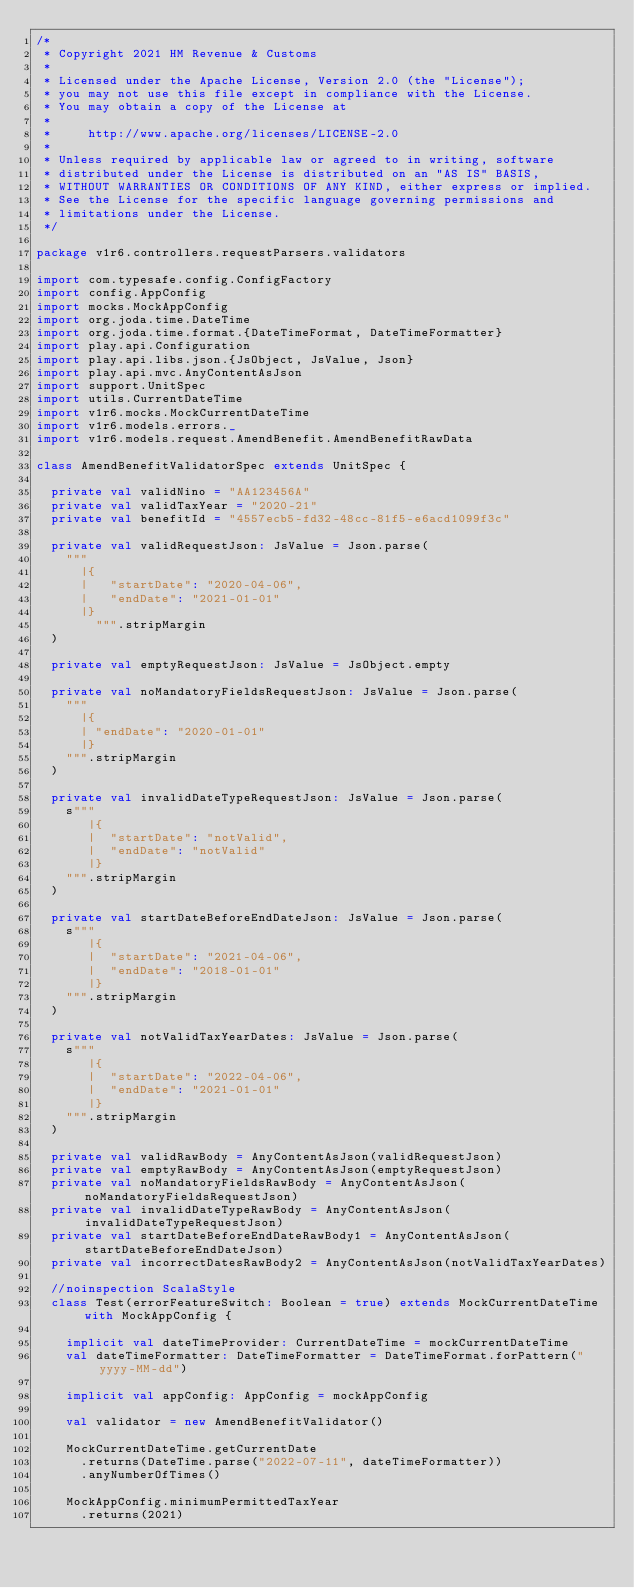Convert code to text. <code><loc_0><loc_0><loc_500><loc_500><_Scala_>/*
 * Copyright 2021 HM Revenue & Customs
 *
 * Licensed under the Apache License, Version 2.0 (the "License");
 * you may not use this file except in compliance with the License.
 * You may obtain a copy of the License at
 *
 *     http://www.apache.org/licenses/LICENSE-2.0
 *
 * Unless required by applicable law or agreed to in writing, software
 * distributed under the License is distributed on an "AS IS" BASIS,
 * WITHOUT WARRANTIES OR CONDITIONS OF ANY KIND, either express or implied.
 * See the License for the specific language governing permissions and
 * limitations under the License.
 */

package v1r6.controllers.requestParsers.validators

import com.typesafe.config.ConfigFactory
import config.AppConfig
import mocks.MockAppConfig
import org.joda.time.DateTime
import org.joda.time.format.{DateTimeFormat, DateTimeFormatter}
import play.api.Configuration
import play.api.libs.json.{JsObject, JsValue, Json}
import play.api.mvc.AnyContentAsJson
import support.UnitSpec
import utils.CurrentDateTime
import v1r6.mocks.MockCurrentDateTime
import v1r6.models.errors._
import v1r6.models.request.AmendBenefit.AmendBenefitRawData

class AmendBenefitValidatorSpec extends UnitSpec {

  private val validNino = "AA123456A"
  private val validTaxYear = "2020-21"
  private val benefitId = "4557ecb5-fd32-48cc-81f5-e6acd1099f3c"

  private val validRequestJson: JsValue = Json.parse(
    """
      |{
      |   "startDate": "2020-04-06",
      |   "endDate": "2021-01-01"
      |}
        """.stripMargin
  )

  private val emptyRequestJson: JsValue = JsObject.empty

  private val noMandatoryFieldsRequestJson: JsValue = Json.parse(
    """
      |{
      | "endDate": "2020-01-01"
      |}
    """.stripMargin
  )

  private val invalidDateTypeRequestJson: JsValue = Json.parse(
    s"""
       |{
       |  "startDate": "notValid",
       |  "endDate": "notValid"
       |}
    """.stripMargin
  )

  private val startDateBeforeEndDateJson: JsValue = Json.parse(
    s"""
       |{
       |  "startDate": "2021-04-06",
       |  "endDate": "2018-01-01"
       |}
    """.stripMargin
  )

  private val notValidTaxYearDates: JsValue = Json.parse(
    s"""
       |{
       |  "startDate": "2022-04-06",
       |  "endDate": "2021-01-01"
       |}
    """.stripMargin
  )

  private val validRawBody = AnyContentAsJson(validRequestJson)
  private val emptyRawBody = AnyContentAsJson(emptyRequestJson)
  private val noMandatoryFieldsRawBody = AnyContentAsJson(noMandatoryFieldsRequestJson)
  private val invalidDateTypeRawBody = AnyContentAsJson(invalidDateTypeRequestJson)
  private val startDateBeforeEndDateRawBody1 = AnyContentAsJson(startDateBeforeEndDateJson)
  private val incorrectDatesRawBody2 = AnyContentAsJson(notValidTaxYearDates)

  //noinspection ScalaStyle
  class Test(errorFeatureSwitch: Boolean = true) extends MockCurrentDateTime with MockAppConfig {

    implicit val dateTimeProvider: CurrentDateTime = mockCurrentDateTime
    val dateTimeFormatter: DateTimeFormatter = DateTimeFormat.forPattern("yyyy-MM-dd")

    implicit val appConfig: AppConfig = mockAppConfig

    val validator = new AmendBenefitValidator()

    MockCurrentDateTime.getCurrentDate
      .returns(DateTime.parse("2022-07-11", dateTimeFormatter))
      .anyNumberOfTimes()

    MockAppConfig.minimumPermittedTaxYear
      .returns(2021)
</code> 